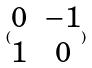<formula> <loc_0><loc_0><loc_500><loc_500>( \begin{matrix} 0 & - 1 \\ 1 & 0 \end{matrix} )</formula> 